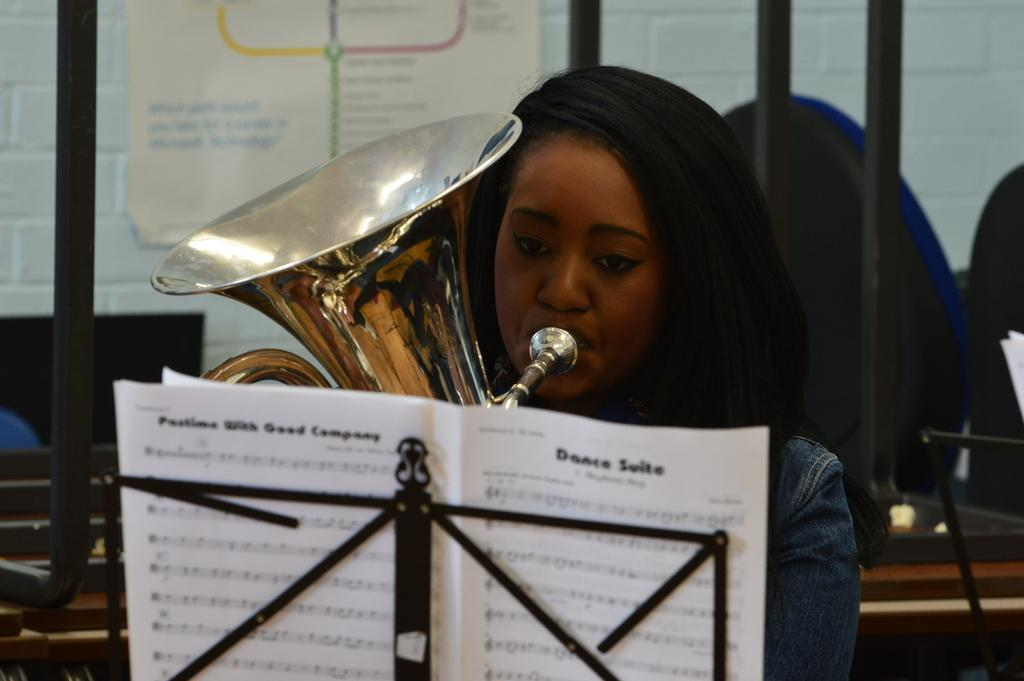What is the woman in the image doing? The woman is playing a musical instrument in the image. What can be seen on the stand in the image? There are papers on the stand in the image. What is hanging on the wall in the background of the image? There is a poster hanging on the wall in the background of the image. What type of objects can be seen in the background of the image? There are objects in the background of the image, but their specific nature is not mentioned in the facts. How many pizzas are being served with the caption "Welcome to the concert" in the image? There is no mention of pizzas or a caption in the image, so this question cannot be answered. 